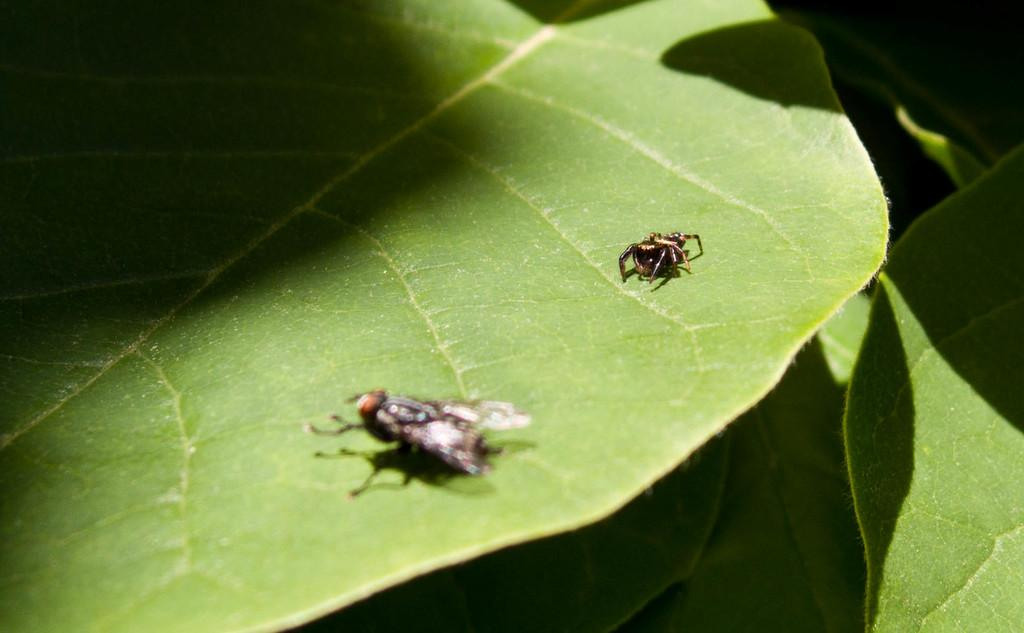What is present on the leaf in the image? There are: There are insects on a leaf in the image. What can be seen at the bottom of the image? There are leaves at the bottom of the image. What type of toothpaste is being used by the insects in the image? There is no toothpaste present in the image; it features insects on a leaf. Can you describe the argument between the frogs in the image? There are no frogs present in the image, so there cannot be an argument between them. 